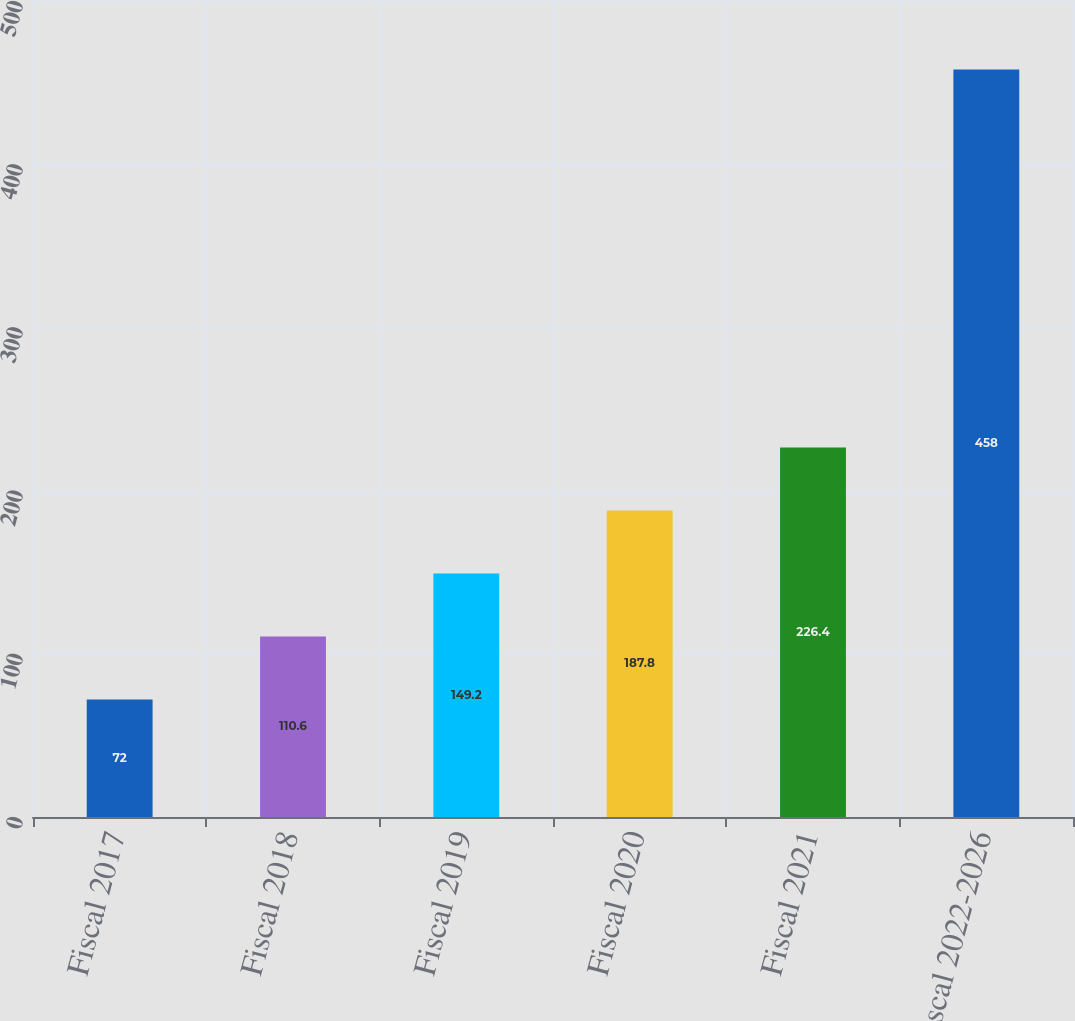Convert chart. <chart><loc_0><loc_0><loc_500><loc_500><bar_chart><fcel>Fiscal 2017<fcel>Fiscal 2018<fcel>Fiscal 2019<fcel>Fiscal 2020<fcel>Fiscal 2021<fcel>Fiscal 2022-2026<nl><fcel>72<fcel>110.6<fcel>149.2<fcel>187.8<fcel>226.4<fcel>458<nl></chart> 